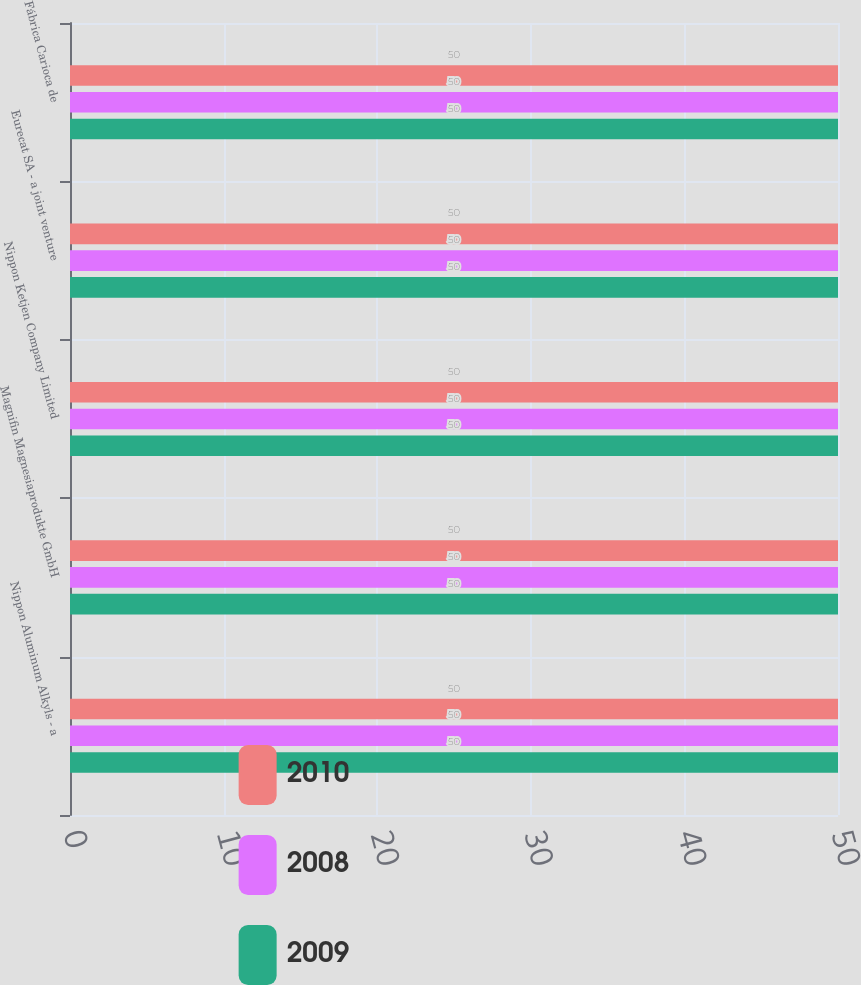Convert chart. <chart><loc_0><loc_0><loc_500><loc_500><stacked_bar_chart><ecel><fcel>Nippon Aluminum Alkyls - a<fcel>Magnifin Magnesiaprodukte GmbH<fcel>Nippon Ketjen Company Limited<fcel>Eurecat SA - a joint venture<fcel>Fábrica Carioca de<nl><fcel>2010<fcel>50<fcel>50<fcel>50<fcel>50<fcel>50<nl><fcel>2008<fcel>50<fcel>50<fcel>50<fcel>50<fcel>50<nl><fcel>2009<fcel>50<fcel>50<fcel>50<fcel>50<fcel>50<nl></chart> 